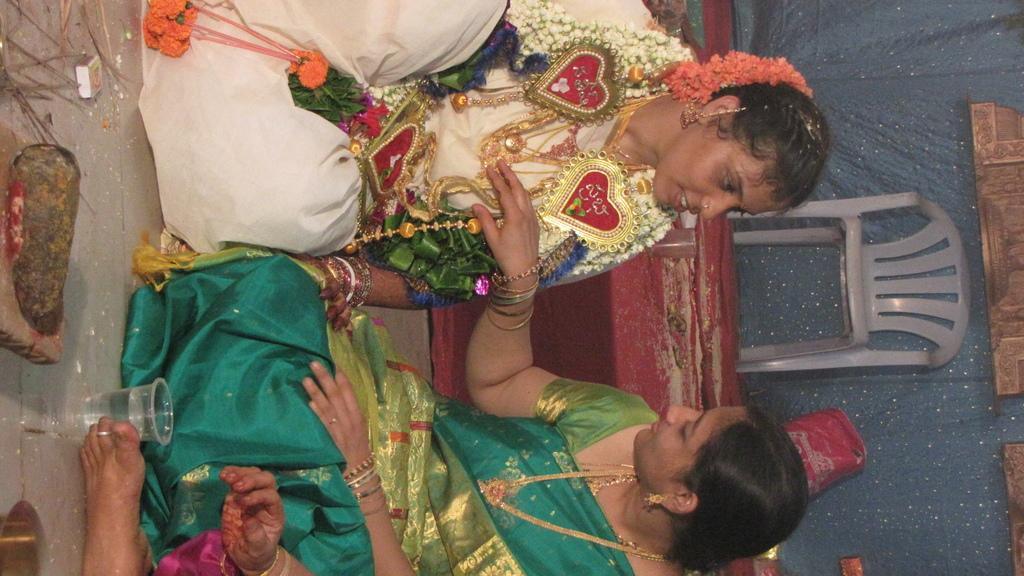How many people are in the group visible in the image? There is a group of people in the image, but the exact number is not specified. What objects are in front of the group of people? There is a glass, a matchbox, and other unspecified things in front of the group of people. What is located behind the group of people? There is a chair and a plastic cover on a table behind the group of people. What type of railway is visible in the image? There is no railway present in the image. What boundary separates the group of people from the objects behind them? There is no boundary visible in the image. 